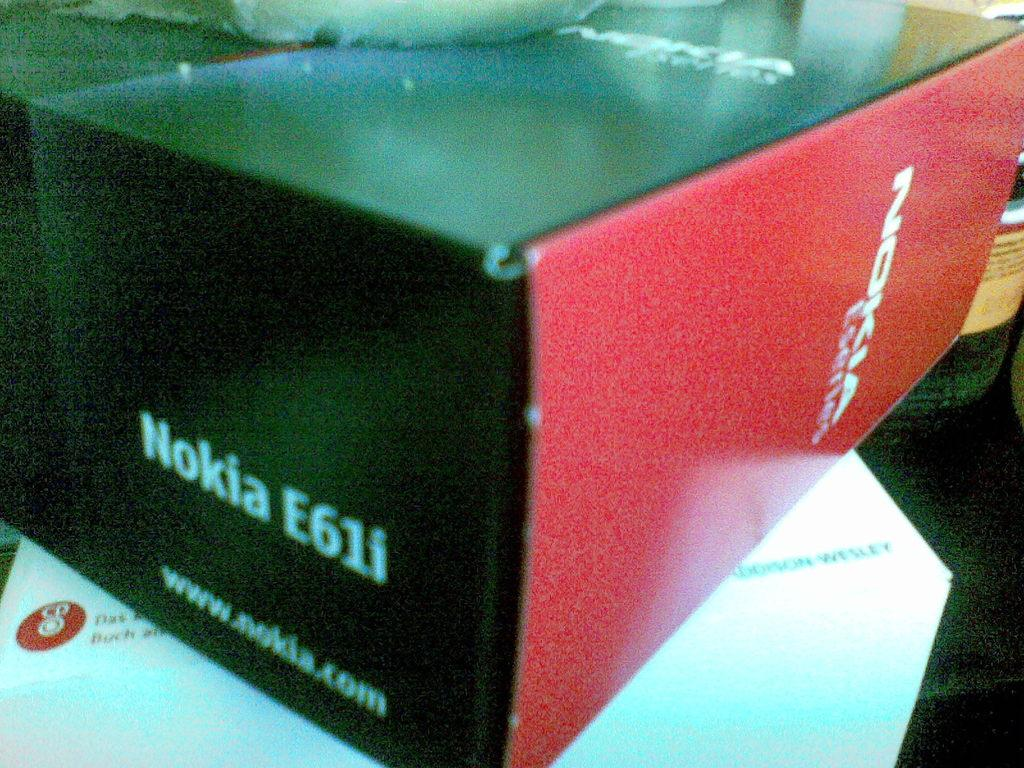<image>
Create a compact narrative representing the image presented. A Nokia E6li comes in a red and black box. 